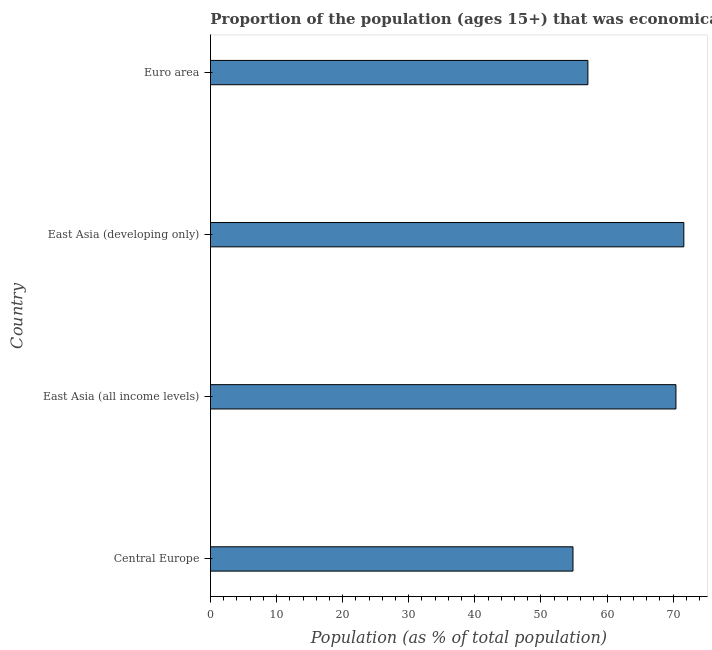Does the graph contain any zero values?
Your answer should be very brief. No. Does the graph contain grids?
Your response must be concise. No. What is the title of the graph?
Your answer should be very brief. Proportion of the population (ages 15+) that was economically active in the year 2008. What is the label or title of the X-axis?
Give a very brief answer. Population (as % of total population). What is the label or title of the Y-axis?
Ensure brevity in your answer.  Country. What is the percentage of economically active population in Euro area?
Ensure brevity in your answer.  57.11. Across all countries, what is the maximum percentage of economically active population?
Provide a succinct answer. 71.62. Across all countries, what is the minimum percentage of economically active population?
Your response must be concise. 54.85. In which country was the percentage of economically active population maximum?
Offer a very short reply. East Asia (developing only). In which country was the percentage of economically active population minimum?
Offer a very short reply. Central Europe. What is the sum of the percentage of economically active population?
Keep it short and to the point. 254.01. What is the difference between the percentage of economically active population in East Asia (developing only) and Euro area?
Offer a very short reply. 14.52. What is the average percentage of economically active population per country?
Provide a short and direct response. 63.5. What is the median percentage of economically active population?
Your answer should be very brief. 63.77. In how many countries, is the percentage of economically active population greater than 8 %?
Provide a succinct answer. 4. What is the ratio of the percentage of economically active population in Central Europe to that in East Asia (developing only)?
Offer a terse response. 0.77. Is the percentage of economically active population in Central Europe less than that in Euro area?
Provide a short and direct response. Yes. Is the difference between the percentage of economically active population in Central Europe and Euro area greater than the difference between any two countries?
Your answer should be compact. No. What is the difference between the highest and the second highest percentage of economically active population?
Your response must be concise. 1.19. Is the sum of the percentage of economically active population in East Asia (all income levels) and Euro area greater than the maximum percentage of economically active population across all countries?
Your answer should be compact. Yes. What is the difference between the highest and the lowest percentage of economically active population?
Offer a very short reply. 16.77. How many bars are there?
Make the answer very short. 4. Are all the bars in the graph horizontal?
Keep it short and to the point. Yes. Are the values on the major ticks of X-axis written in scientific E-notation?
Ensure brevity in your answer.  No. What is the Population (as % of total population) of Central Europe?
Your answer should be compact. 54.85. What is the Population (as % of total population) in East Asia (all income levels)?
Your answer should be very brief. 70.43. What is the Population (as % of total population) in East Asia (developing only)?
Offer a very short reply. 71.62. What is the Population (as % of total population) of Euro area?
Keep it short and to the point. 57.11. What is the difference between the Population (as % of total population) in Central Europe and East Asia (all income levels)?
Your response must be concise. -15.58. What is the difference between the Population (as % of total population) in Central Europe and East Asia (developing only)?
Keep it short and to the point. -16.77. What is the difference between the Population (as % of total population) in Central Europe and Euro area?
Offer a terse response. -2.26. What is the difference between the Population (as % of total population) in East Asia (all income levels) and East Asia (developing only)?
Your response must be concise. -1.19. What is the difference between the Population (as % of total population) in East Asia (all income levels) and Euro area?
Offer a terse response. 13.32. What is the difference between the Population (as % of total population) in East Asia (developing only) and Euro area?
Make the answer very short. 14.51. What is the ratio of the Population (as % of total population) in Central Europe to that in East Asia (all income levels)?
Make the answer very short. 0.78. What is the ratio of the Population (as % of total population) in Central Europe to that in East Asia (developing only)?
Your answer should be very brief. 0.77. What is the ratio of the Population (as % of total population) in East Asia (all income levels) to that in East Asia (developing only)?
Offer a terse response. 0.98. What is the ratio of the Population (as % of total population) in East Asia (all income levels) to that in Euro area?
Provide a succinct answer. 1.23. What is the ratio of the Population (as % of total population) in East Asia (developing only) to that in Euro area?
Make the answer very short. 1.25. 